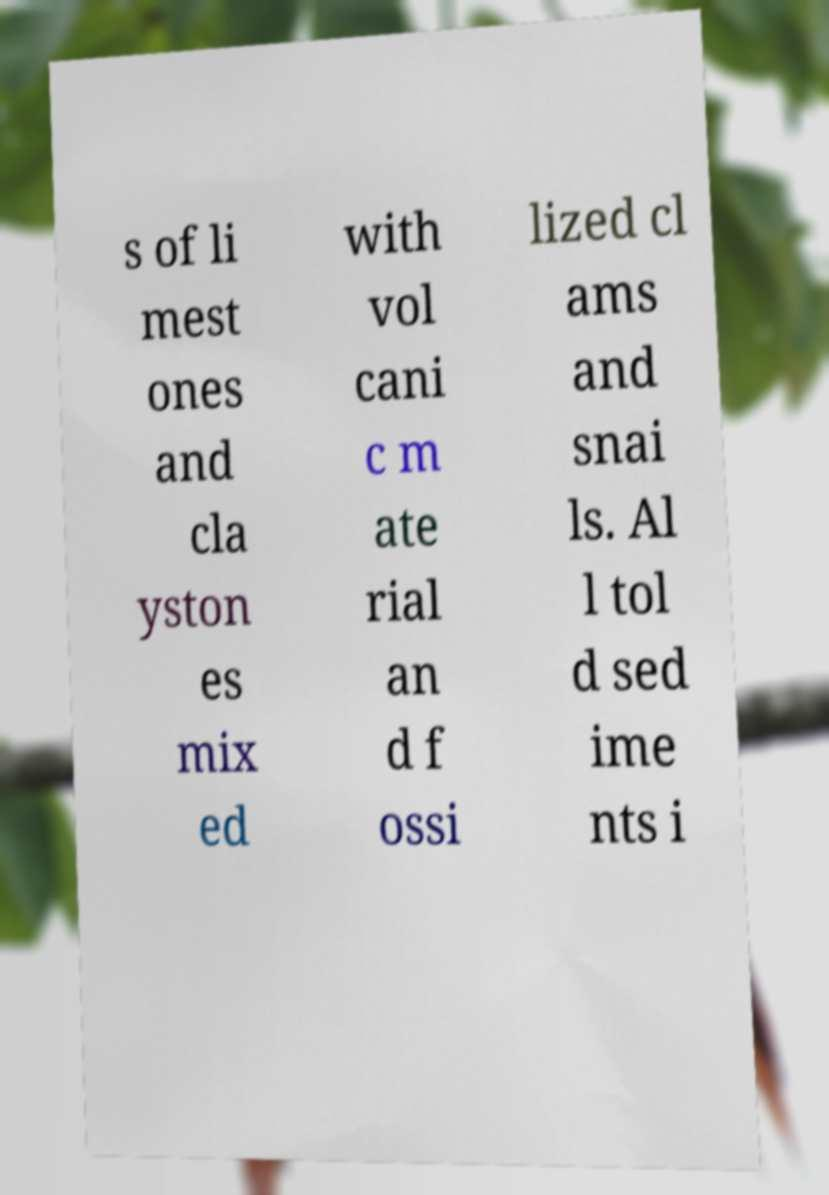Can you read and provide the text displayed in the image?This photo seems to have some interesting text. Can you extract and type it out for me? s of li mest ones and cla yston es mix ed with vol cani c m ate rial an d f ossi lized cl ams and snai ls. Al l tol d sed ime nts i 